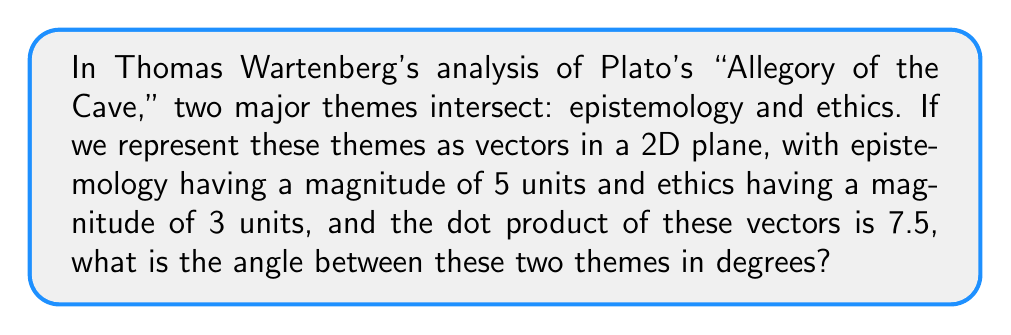Solve this math problem. Let's approach this step-by-step using vector algebra and trigonometry:

1) Let $\vec{a}$ represent the epistemology theme and $\vec{b}$ represent the ethics theme.

2) We know:
   $|\vec{a}| = 5$ (magnitude of epistemology vector)
   $|\vec{b}| = 3$ (magnitude of ethics vector)
   $\vec{a} \cdot \vec{b} = 7.5$ (dot product)

3) The dot product formula states:
   $$\vec{a} \cdot \vec{b} = |\vec{a}||\vec{b}|\cos(\theta)$$
   where $\theta$ is the angle between the vectors.

4) Substituting our known values:
   $$7.5 = 5 \cdot 3 \cdot \cos(\theta)$$

5) Simplify:
   $$7.5 = 15\cos(\theta)$$

6) Divide both sides by 15:
   $$\frac{7.5}{15} = \cos(\theta)$$
   $$0.5 = \cos(\theta)$$

7) To find $\theta$, we need to take the inverse cosine (arccos) of both sides:
   $$\theta = \arccos(0.5)$$

8) Calculate:
   $$\theta \approx 60^\circ$$

Thus, the angle between the two themes is approximately 60 degrees.
Answer: $60^\circ$ 